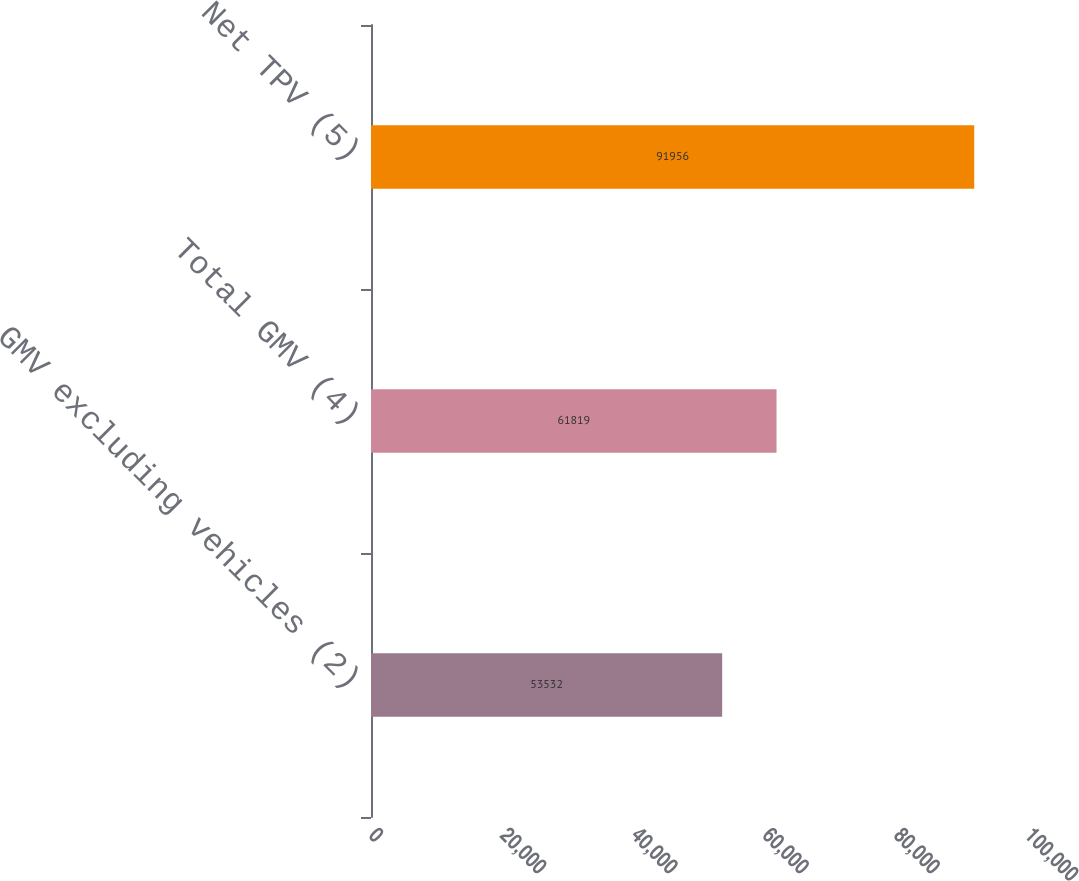Convert chart to OTSL. <chart><loc_0><loc_0><loc_500><loc_500><bar_chart><fcel>GMV excluding vehicles (2)<fcel>Total GMV (4)<fcel>Net TPV (5)<nl><fcel>53532<fcel>61819<fcel>91956<nl></chart> 